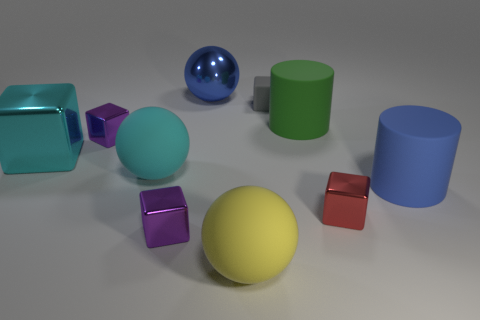There is a big block that is in front of the gray object; what number of large rubber things are behind it?
Your answer should be very brief. 1. Do the blue thing in front of the big cyan matte ball and the green matte thing that is behind the cyan metal cube have the same shape?
Give a very brief answer. Yes. How big is the thing that is to the right of the blue metallic thing and in front of the red shiny block?
Provide a succinct answer. Large. What is the color of the other rubber object that is the same shape as the large green thing?
Your answer should be compact. Blue. There is a ball that is behind the purple thing behind the red object; what color is it?
Provide a succinct answer. Blue. What is the shape of the big cyan rubber thing?
Your response must be concise. Sphere. What is the shape of the thing that is both to the left of the blue metallic ball and in front of the small red object?
Provide a succinct answer. Cube. The small block that is made of the same material as the big cyan sphere is what color?
Your answer should be very brief. Gray. The blue thing that is in front of the large sphere behind the green matte cylinder that is on the right side of the big cyan matte sphere is what shape?
Your response must be concise. Cylinder. The blue cylinder has what size?
Your answer should be compact. Large. 